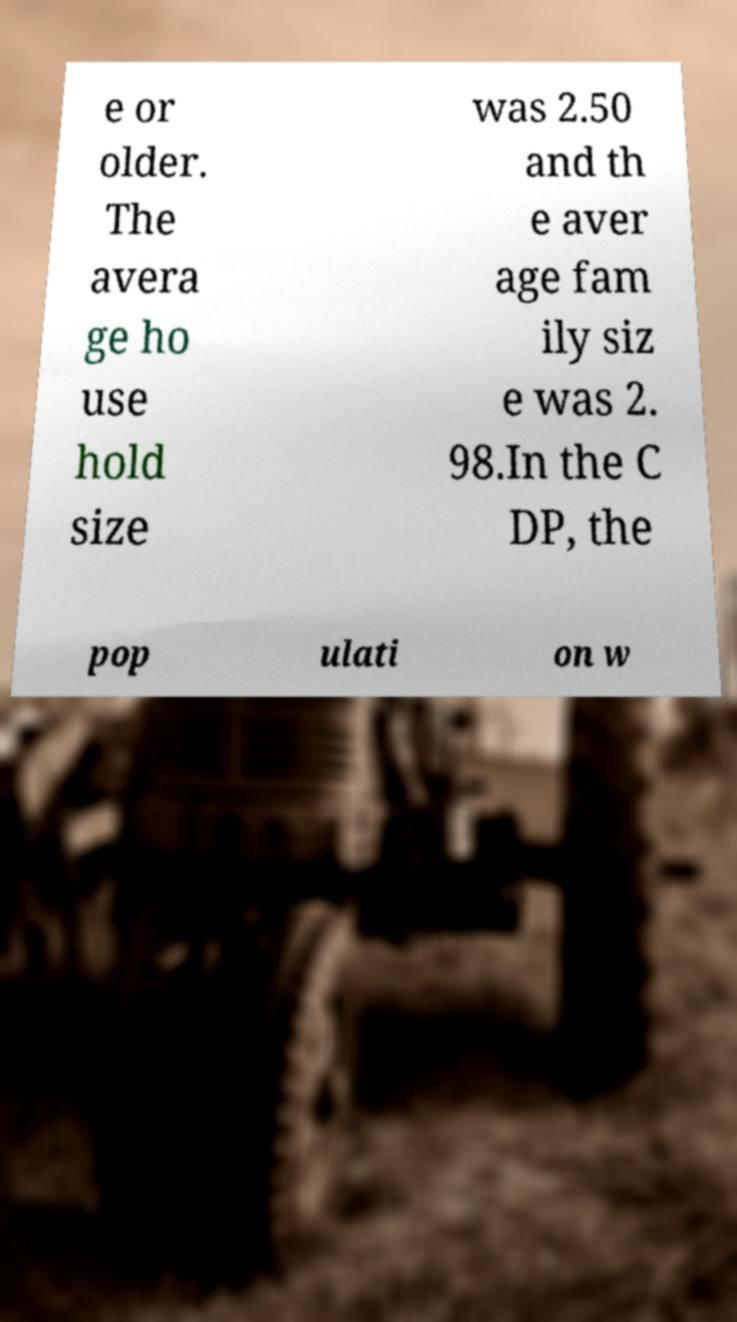I need the written content from this picture converted into text. Can you do that? e or older. The avera ge ho use hold size was 2.50 and th e aver age fam ily siz e was 2. 98.In the C DP, the pop ulati on w 